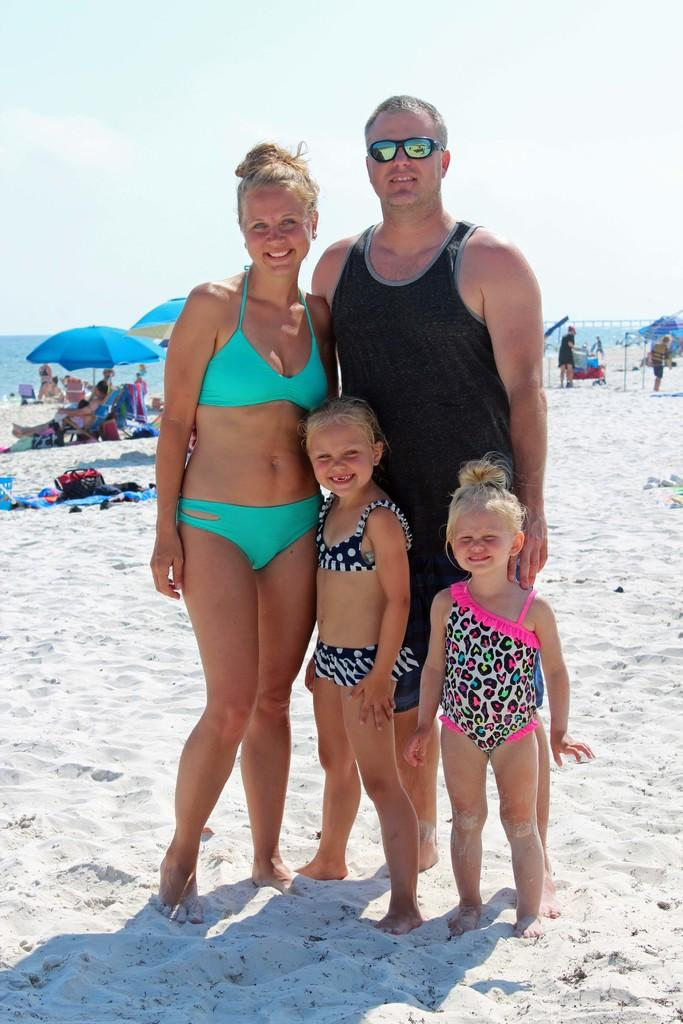How many people are standing on the sand in the image? There are 4 people standing on the sand in the image. What is one person wearing that is not typical for standing on the sand? One person is wearing goggles. What objects can be seen providing shade in the image? There are umbrellas in the image. Can you describe the presence of other people in the image? There are other people visible in the image. What type of natural feature is present at the back of the image? Water is present at the back of the image. What is visible at the top of the image? The sky is visible at the top of the image. What type of waste can be seen being disposed of in the image? There is no waste present in the image; it features people standing on the sand, umbrellas, and water. What amusement park ride can be seen in the image? There is no amusement park ride present in the image. 